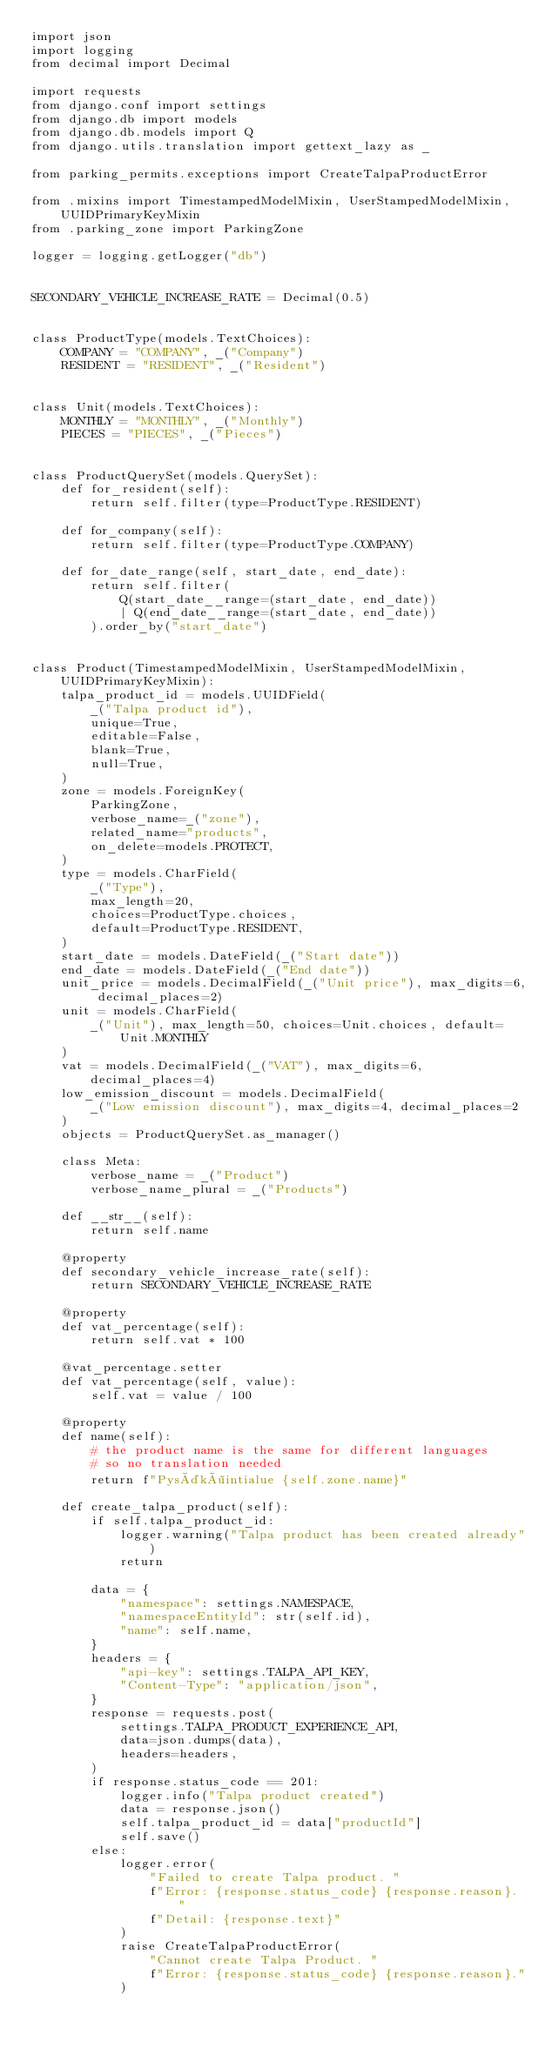Convert code to text. <code><loc_0><loc_0><loc_500><loc_500><_Python_>import json
import logging
from decimal import Decimal

import requests
from django.conf import settings
from django.db import models
from django.db.models import Q
from django.utils.translation import gettext_lazy as _

from parking_permits.exceptions import CreateTalpaProductError

from .mixins import TimestampedModelMixin, UserStampedModelMixin, UUIDPrimaryKeyMixin
from .parking_zone import ParkingZone

logger = logging.getLogger("db")


SECONDARY_VEHICLE_INCREASE_RATE = Decimal(0.5)


class ProductType(models.TextChoices):
    COMPANY = "COMPANY", _("Company")
    RESIDENT = "RESIDENT", _("Resident")


class Unit(models.TextChoices):
    MONTHLY = "MONTHLY", _("Monthly")
    PIECES = "PIECES", _("Pieces")


class ProductQuerySet(models.QuerySet):
    def for_resident(self):
        return self.filter(type=ProductType.RESIDENT)

    def for_company(self):
        return self.filter(type=ProductType.COMPANY)

    def for_date_range(self, start_date, end_date):
        return self.filter(
            Q(start_date__range=(start_date, end_date))
            | Q(end_date__range=(start_date, end_date))
        ).order_by("start_date")


class Product(TimestampedModelMixin, UserStampedModelMixin, UUIDPrimaryKeyMixin):
    talpa_product_id = models.UUIDField(
        _("Talpa product id"),
        unique=True,
        editable=False,
        blank=True,
        null=True,
    )
    zone = models.ForeignKey(
        ParkingZone,
        verbose_name=_("zone"),
        related_name="products",
        on_delete=models.PROTECT,
    )
    type = models.CharField(
        _("Type"),
        max_length=20,
        choices=ProductType.choices,
        default=ProductType.RESIDENT,
    )
    start_date = models.DateField(_("Start date"))
    end_date = models.DateField(_("End date"))
    unit_price = models.DecimalField(_("Unit price"), max_digits=6, decimal_places=2)
    unit = models.CharField(
        _("Unit"), max_length=50, choices=Unit.choices, default=Unit.MONTHLY
    )
    vat = models.DecimalField(_("VAT"), max_digits=6, decimal_places=4)
    low_emission_discount = models.DecimalField(
        _("Low emission discount"), max_digits=4, decimal_places=2
    )
    objects = ProductQuerySet.as_manager()

    class Meta:
        verbose_name = _("Product")
        verbose_name_plural = _("Products")

    def __str__(self):
        return self.name

    @property
    def secondary_vehicle_increase_rate(self):
        return SECONDARY_VEHICLE_INCREASE_RATE

    @property
    def vat_percentage(self):
        return self.vat * 100

    @vat_percentage.setter
    def vat_percentage(self, value):
        self.vat = value / 100

    @property
    def name(self):
        # the product name is the same for different languages
        # so no translation needed
        return f"Pysäköintialue {self.zone.name}"

    def create_talpa_product(self):
        if self.talpa_product_id:
            logger.warning("Talpa product has been created already")
            return

        data = {
            "namespace": settings.NAMESPACE,
            "namespaceEntityId": str(self.id),
            "name": self.name,
        }
        headers = {
            "api-key": settings.TALPA_API_KEY,
            "Content-Type": "application/json",
        }
        response = requests.post(
            settings.TALPA_PRODUCT_EXPERIENCE_API,
            data=json.dumps(data),
            headers=headers,
        )
        if response.status_code == 201:
            logger.info("Talpa product created")
            data = response.json()
            self.talpa_product_id = data["productId"]
            self.save()
        else:
            logger.error(
                "Failed to create Talpa product. "
                f"Error: {response.status_code} {response.reason}. "
                f"Detail: {response.text}"
            )
            raise CreateTalpaProductError(
                "Cannot create Talpa Product. "
                f"Error: {response.status_code} {response.reason}."
            )
</code> 